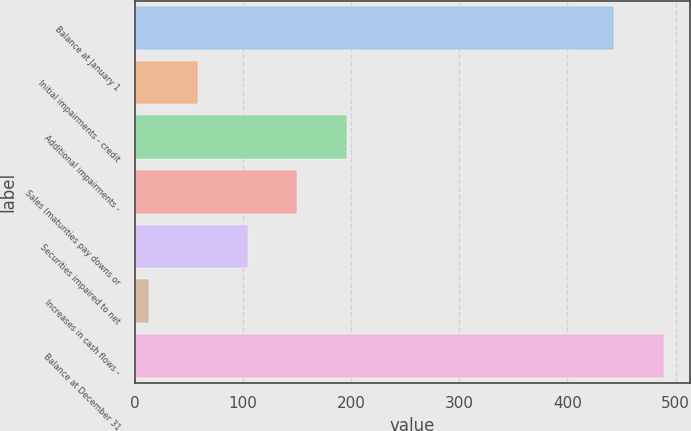<chart> <loc_0><loc_0><loc_500><loc_500><bar_chart><fcel>Balance at January 1<fcel>Initial impairments - credit<fcel>Additional impairments -<fcel>Sales (maturities pay downs or<fcel>Securities impaired to net<fcel>Increases in cash flows -<fcel>Balance at December 31<nl><fcel>443<fcel>58.8<fcel>196.2<fcel>150.4<fcel>104.6<fcel>13<fcel>488.8<nl></chart> 